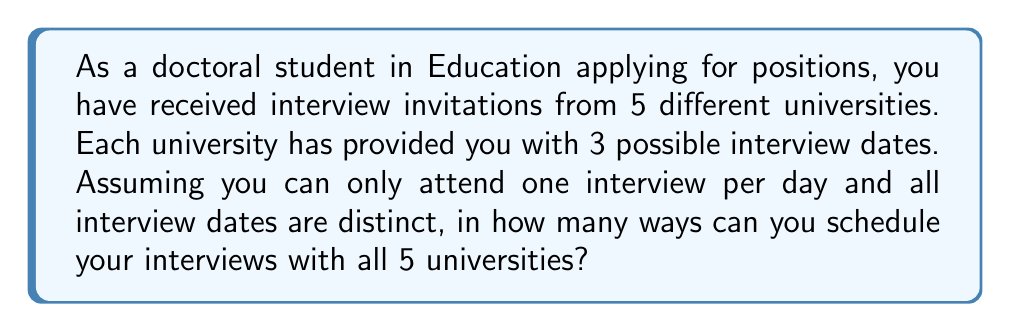Could you help me with this problem? Let's approach this step-by-step:

1) First, we need to recognize that this is a permutation problem. We are selecting 5 dates out of the 15 total dates provided (3 dates for each of the 5 universities).

2) For the first interview, we have 15 choices, as we can choose any of the dates offered by any of the universities.

3) For the second interview, we have 14 choices remaining, as one date has been used.

4) This pattern continues: 13 choices for the third interview, 12 for the fourth, and 11 for the last interview.

5) The multiplication principle states that if we have a series of choices, where the number of choices for each decision is independent of the other choices, we multiply the number of possibilities for each choice.

6) Therefore, the total number of ways to schedule the interviews is:

   $$15 \times 14 \times 13 \times 12 \times 11$$

7) This can also be written as a permutation:

   $$P(15,5) = \frac{15!}{(15-5)!} = \frac{15!}{10!}$$

8) Calculating this:
   
   $$15 \times 14 \times 13 \times 12 \times 11 = 360,360$$

Thus, there are 360,360 ways to schedule the interviews.
Answer: 360,360 